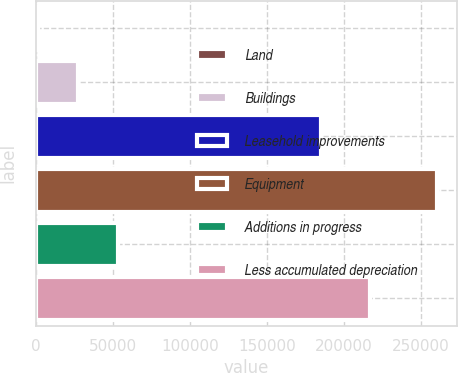<chart> <loc_0><loc_0><loc_500><loc_500><bar_chart><fcel>Land<fcel>Buildings<fcel>Leasehold improvements<fcel>Equipment<fcel>Additions in progress<fcel>Less accumulated depreciation<nl><fcel>1039<fcel>26949.3<fcel>184764<fcel>260142<fcel>52859.6<fcel>216753<nl></chart> 